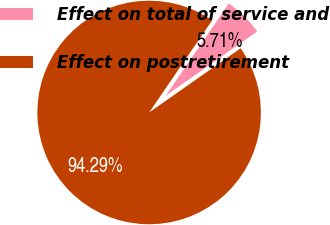Convert chart to OTSL. <chart><loc_0><loc_0><loc_500><loc_500><pie_chart><fcel>Effect on total of service and<fcel>Effect on postretirement<nl><fcel>5.71%<fcel>94.29%<nl></chart> 